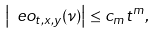<formula> <loc_0><loc_0><loc_500><loc_500>\left | \ e o _ { t , x , y } ( \nu ) \right | \leq c _ { m } t ^ { m } ,</formula> 